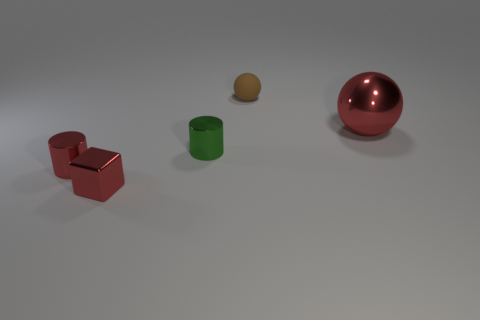How many small shiny cylinders are the same color as the metal sphere?
Your response must be concise. 1. How many cubes are either large yellow metallic things or small red metallic things?
Provide a short and direct response. 1. There is a ball right of the small sphere; what color is it?
Give a very brief answer. Red. There is a brown rubber thing that is the same size as the cube; what is its shape?
Make the answer very short. Sphere. How many green things are behind the small brown sphere?
Give a very brief answer. 0. How many objects are either tiny matte blocks or big red metallic objects?
Provide a succinct answer. 1. There is a thing that is both to the right of the tiny green shiny object and left of the large red metallic sphere; what shape is it?
Give a very brief answer. Sphere. What number of rubber spheres are there?
Offer a very short reply. 1. There is a big object that is the same material as the red block; what color is it?
Provide a succinct answer. Red. Are there more brown matte things than cyan rubber cylinders?
Offer a terse response. Yes. 